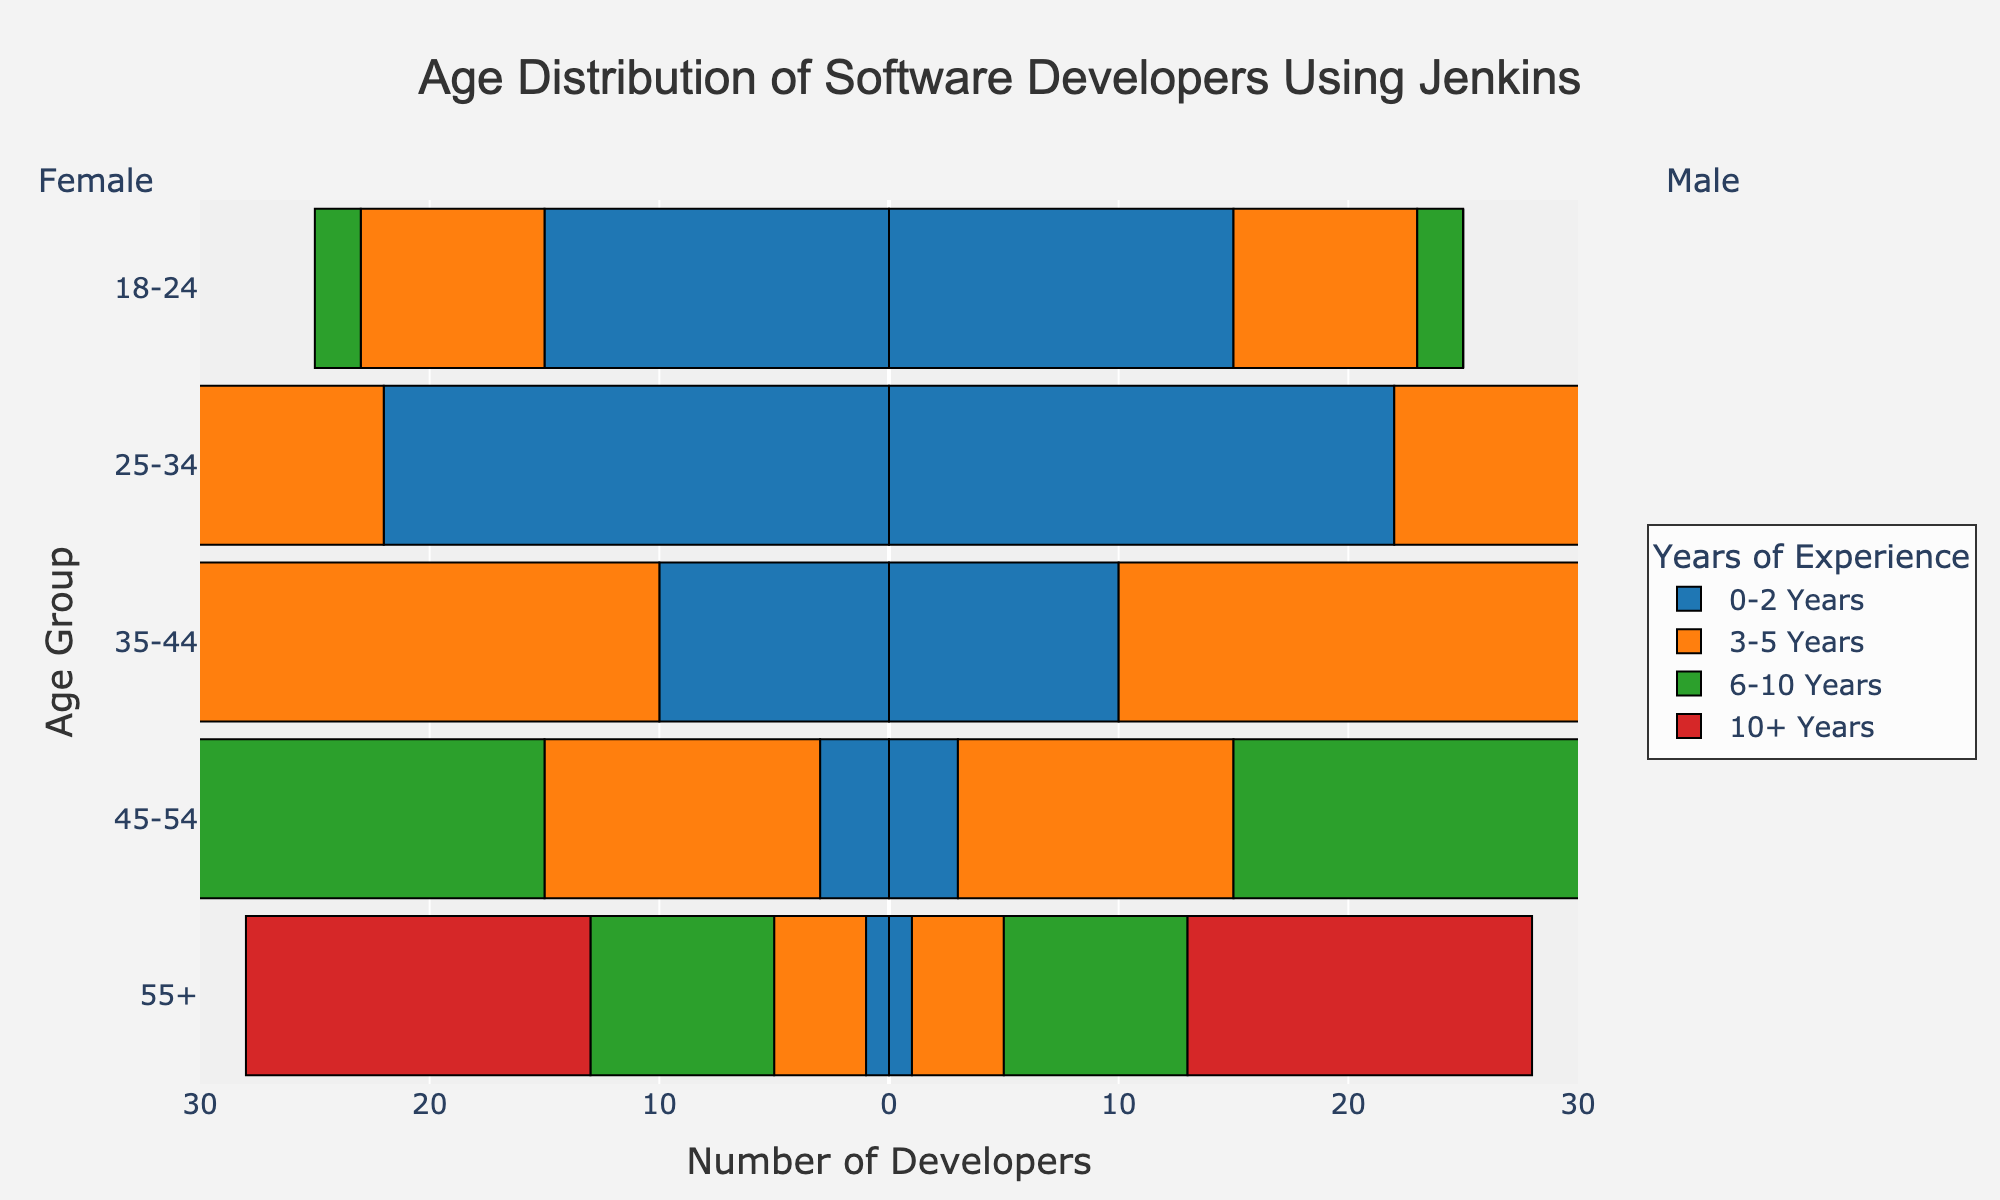What is the main title of the figure? The main title is typically placed at the top center of the figure. For this specific chart, it is written in a large, prominent font.
Answer: Age Distribution of Software Developers Using Jenkins Which experience category has the highest number of developers in the 25-34 age group? By observing the height of the bars corresponding to the 25-34 age group, you can see that the 3-5 Years category has the tallest bar, indicating the highest number.
Answer: 3-5 Years How many developers with 0-2 years of experience are in the 18-24 age group? Find the bar representing the 0-2 Years category in the 18-24 age group and read the value.
Answer: 15 For the 10+ years experience category, which age group has the most developers? In the 10+ Years category, compare the lengths of the bars across all age groups. The one with the longest bar will have the most developers.
Answer: 45-54 What is the total number of developers aged 35-44 with 6-10 years of experience? Identify the value of the bar in the 35-44 age group and 6-10 Years category.
Answer: 28 Which age group has the least number of developers with 0-2 years of experience? Compare the bars for the 0-2 Years experience category across all age groups. The one with the shortest bar has the least number of developers.
Answer: 55+ In the 45-54 age group, how many more developers have 10+ years of experience compared to those with 0-2 years of experience? Subtract the number of developers with 0-2 years of experience in the 45-54 age group from those with 10+ years of experience in the same age group.
Answer: 22 (25 - 3) Which experience category has the broadest range of developer ages? Look at the bars across all age groups for each experience category, and the category encompassing most age groups indicates the broadest range.
Answer: 6-10 Years What is the total number of developers aged 18-24 across all experience categories? Sum the values of the bars in the 18-24 age group across all experience categories: 15 + 8 + 2 + 0.
Answer: 25 In the 35-44 age group, is the number of developers with 10+ years of experience greater than those with 3-5 years of experience? Compare the lengths of the bars representing the 10+ Years and 3-5 Years categories in the 35-44 age group. The bar with the greater value indicates the answer.
Answer: Yes 